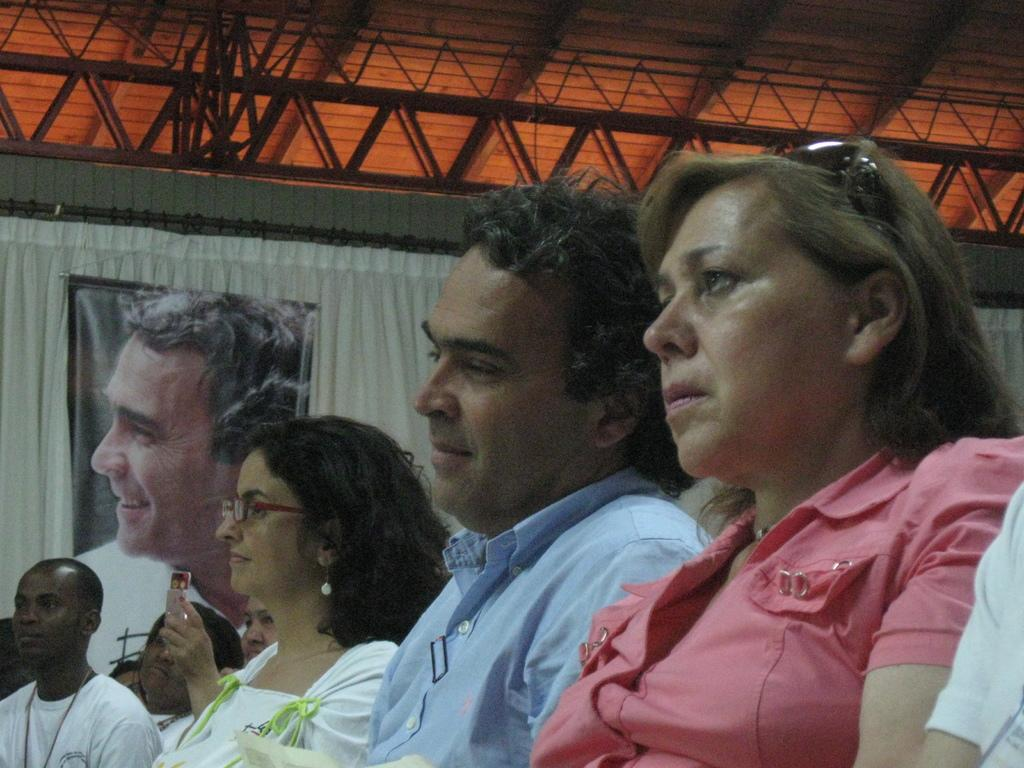What are the people in the image doing? The people in the image are sitting on chairs. What can be seen in the background of the image? There is a curtain in the background of the image. What is depicted on the curtain? There is a poster of a man on the curtain. What type of outdoor environment is visible in the image? There are roads visible in the image. What type of structure is present in the image? There is an iron frame in the image. What type of blade is being used by the people in the image? There is no blade present in the image. 